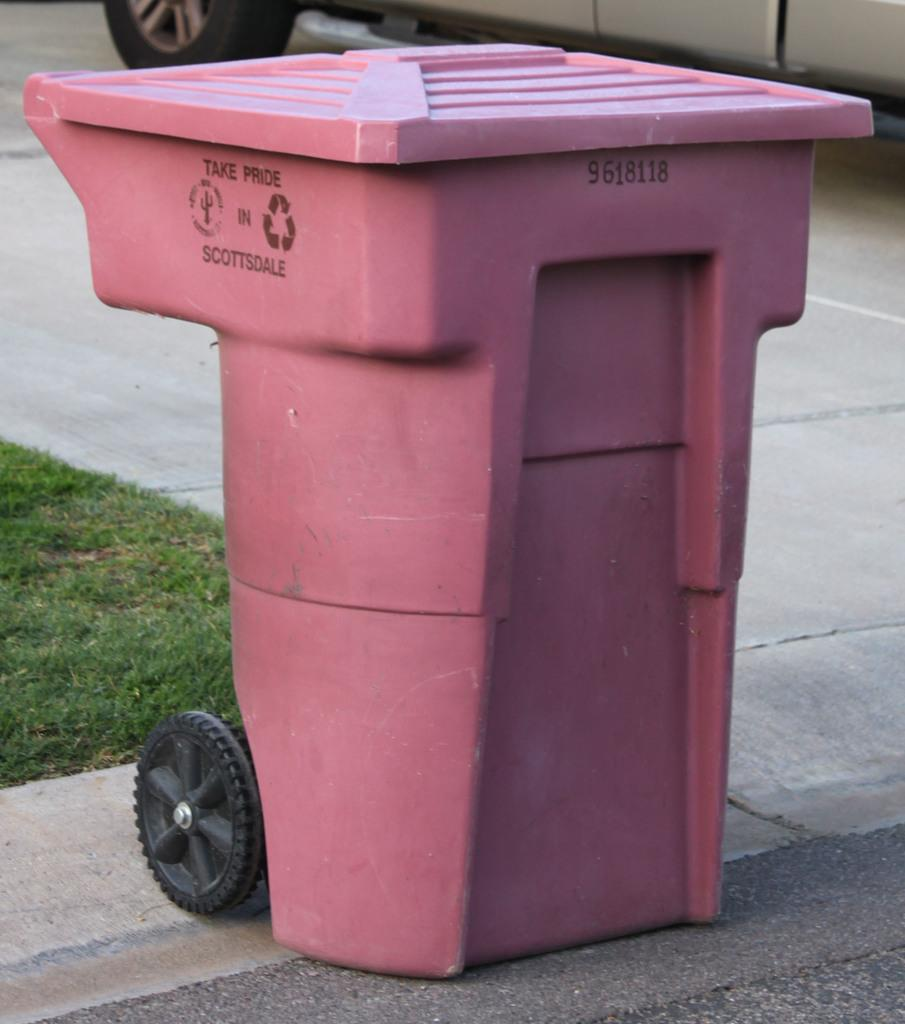Provide a one-sentence caption for the provided image. A pink trash can in Scottsdale sits on the curb. 